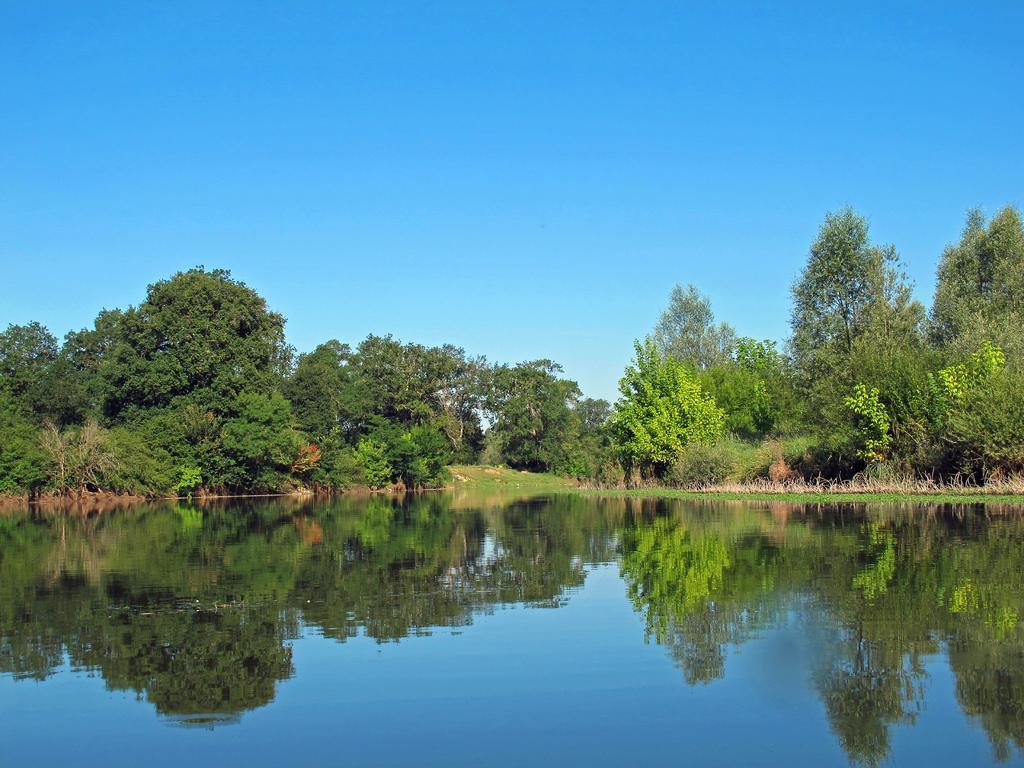How would you summarize this image in a sentence or two? In this image there are few trees, reflections of trees in the water and the sky. 